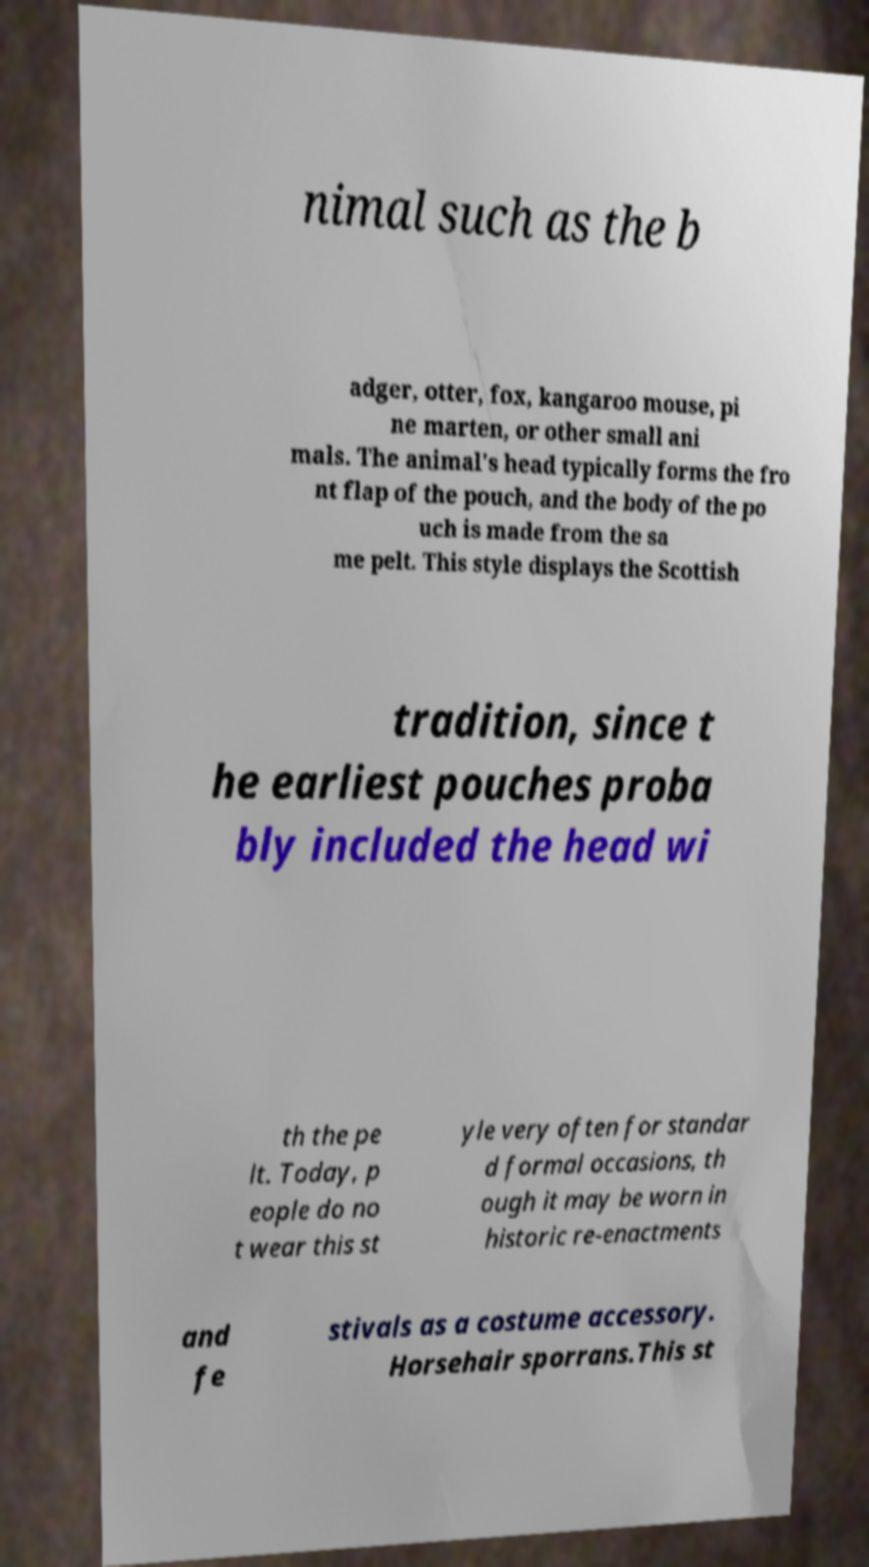Could you extract and type out the text from this image? nimal such as the b adger, otter, fox, kangaroo mouse, pi ne marten, or other small ani mals. The animal's head typically forms the fro nt flap of the pouch, and the body of the po uch is made from the sa me pelt. This style displays the Scottish tradition, since t he earliest pouches proba bly included the head wi th the pe lt. Today, p eople do no t wear this st yle very often for standar d formal occasions, th ough it may be worn in historic re-enactments and fe stivals as a costume accessory. Horsehair sporrans.This st 